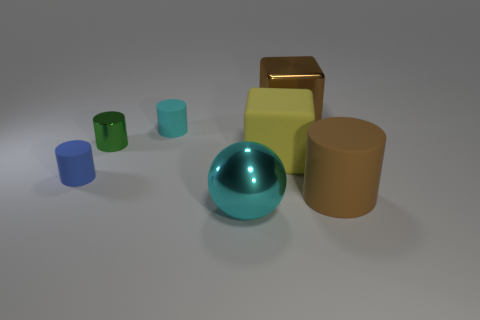There is a object that is the same color as the big cylinder; what is its size?
Provide a short and direct response. Large. What is the shape of the big matte thing that is the same color as the big metal block?
Keep it short and to the point. Cylinder. The cyan thing in front of the big yellow matte cube has what shape?
Make the answer very short. Sphere. Does the metal sphere have the same color as the large rubber thing in front of the small blue object?
Offer a terse response. No. Are there the same number of small blue matte cylinders that are on the right side of the tiny green metallic thing and brown shiny things right of the big brown block?
Your answer should be compact. Yes. What number of other objects are there of the same size as the green cylinder?
Your response must be concise. 2. How big is the rubber cube?
Ensure brevity in your answer.  Large. Do the big cyan object and the big block that is in front of the tiny cyan thing have the same material?
Your response must be concise. No. Are there any red shiny objects of the same shape as the yellow object?
Offer a terse response. No. What is the material of the other cyan cylinder that is the same size as the metallic cylinder?
Offer a terse response. Rubber. 